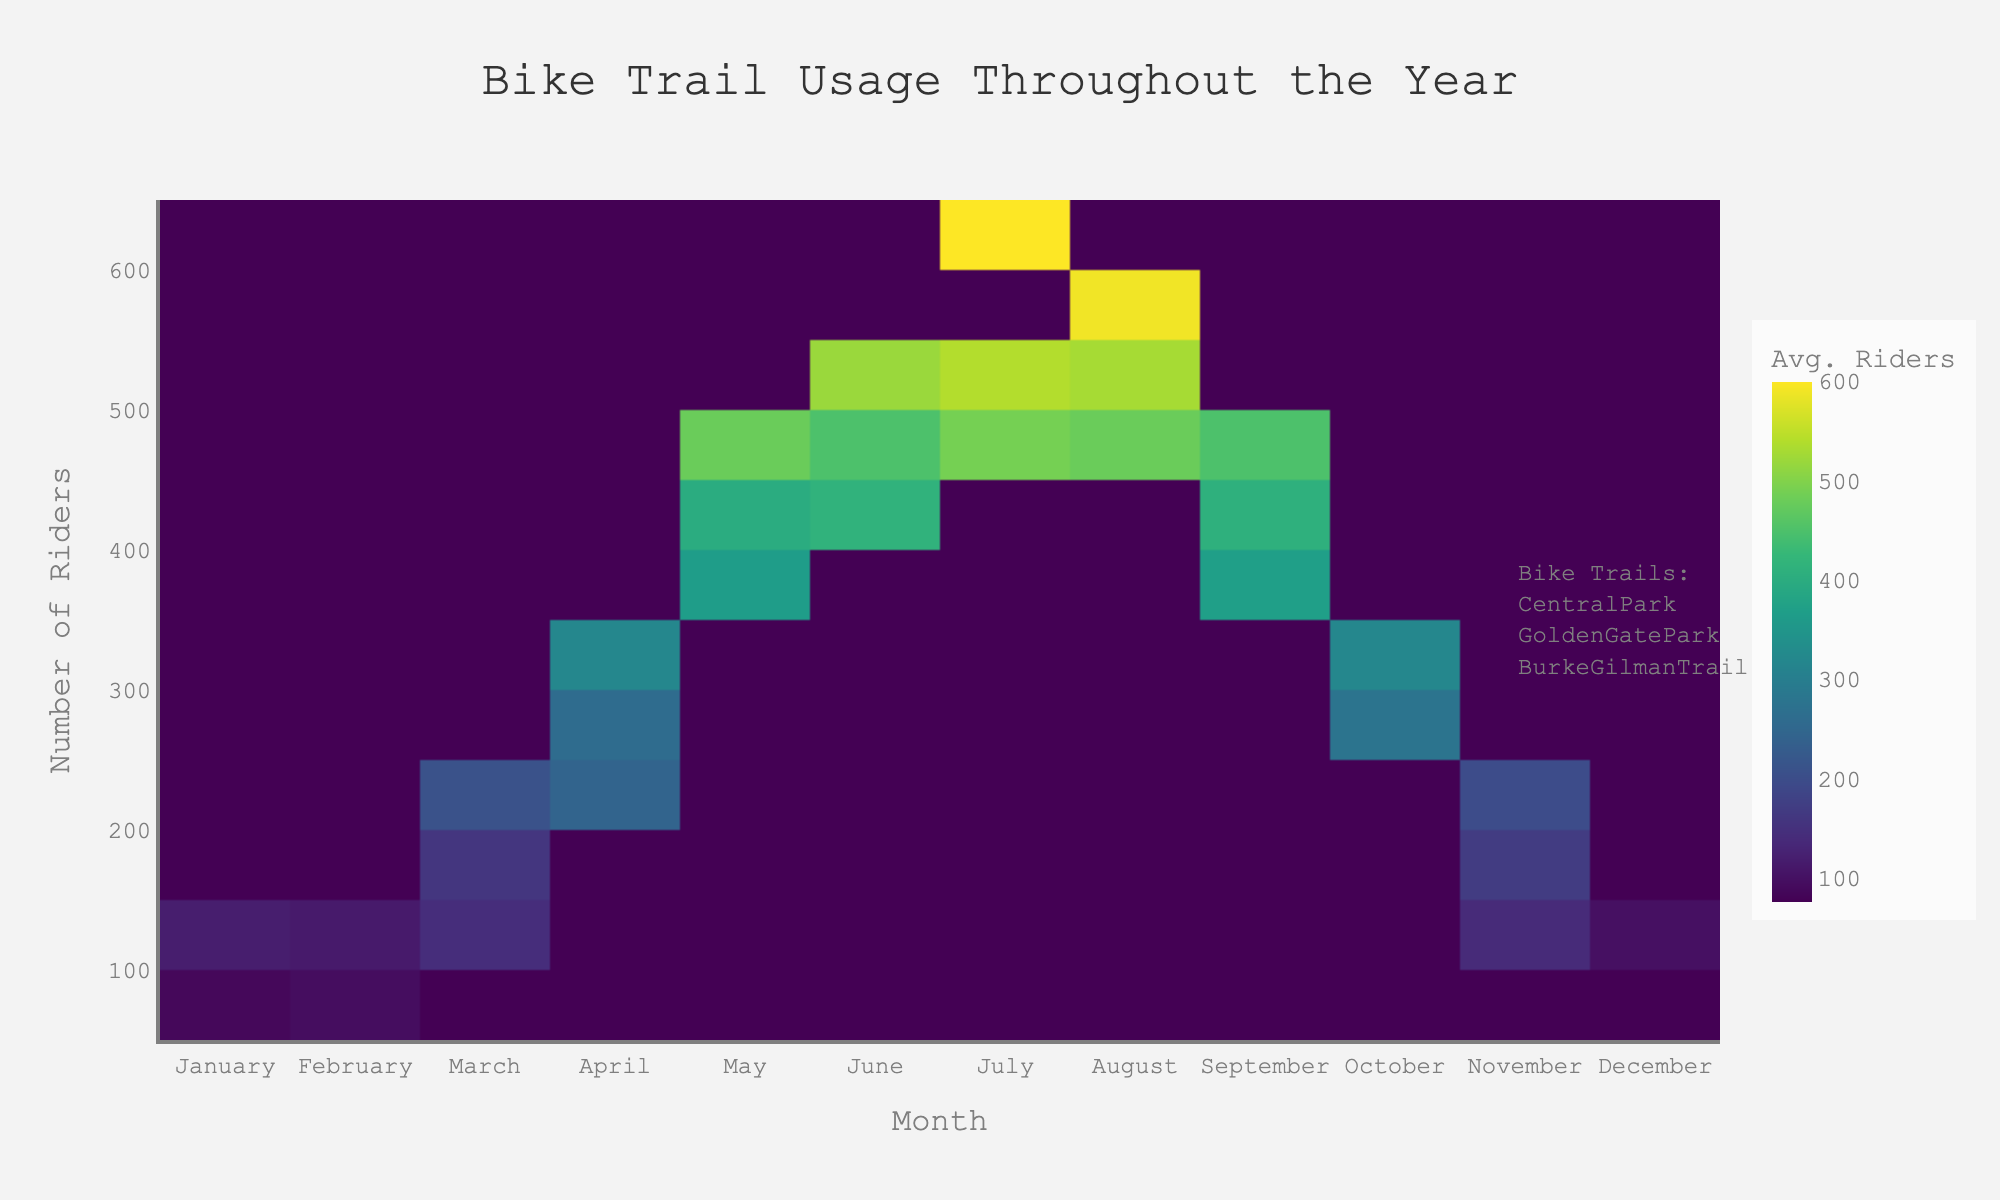What is the title of the figure? The title is typically displayed at the top center of the figure. In this case, it is "Bike Trail Usage Throughout the Year".
Answer: Bike Trail Usage Throughout the Year Which month shows the highest average number of riders? By examining the density colors and the y-axis, July has the highest average number of riders as it has the darkest color indicating the highest density.
Answer: July Which month has the lowest average number of riders? The month with the lowest average number of riders has the lightest color density on the figure. December exhibits the lightest color, indicating the lowest average number of riders.
Answer: December How does the number of riders change from April to May? Observing the color change from April to May, it shows an increase in density. The darker color in May signifies a higher number of riders compared to April.
Answer: Increases What is the average number of riders for March in both Central Park and Golden Gate Park? Find the corresponding y-values for March in the categories Central Park and Golden Gate Park and calculate the average. March in Central Park has around 210 riders, and Golden Gate Park has about 145 riders. The average of 210 and 145 is (210 + 145) / 2 = 177.5
Answer: 177.5 Which bike trail appears to have the most consistent usage throughout the year? Consistency can be observed by the uniformity of the color density throughout the months. Golden Gate Park shows a more consistent color pattern throughout the year compared to the Central Park and Burke Gilman Trail.
Answer: Golden Gate Park Which months have similar rider densities for Burke Gilman Trail? By comparing the colors specifically related to Burke Gilman Trail, April and May have similar densities. Both months have comparable dark colors indicating similar rider counts.
Answer: April and May Does Central Park experience any seasonal spikes in usage? Seasonal spikes are indicated by changes in density color. Central Park shows a significant increase in density from April reaching a peak in July, suggesting seasonal spikes.
Answer: Yes, peaks around July How does rider count in October compare to November for Central Park? Comparing the density color for October and November for Central Park, October shows a darker color than November indicating a higher number of riders in October.
Answer: October has higher ridership Is there any month where the rider count is similar across all three bike trails? By finding a month where the colors are almost uniform across all bike trails, September shows closer densities, indicating similar rider counts across Central Park, Golden Gate Park, and Burke Gilman Trail.
Answer: September 